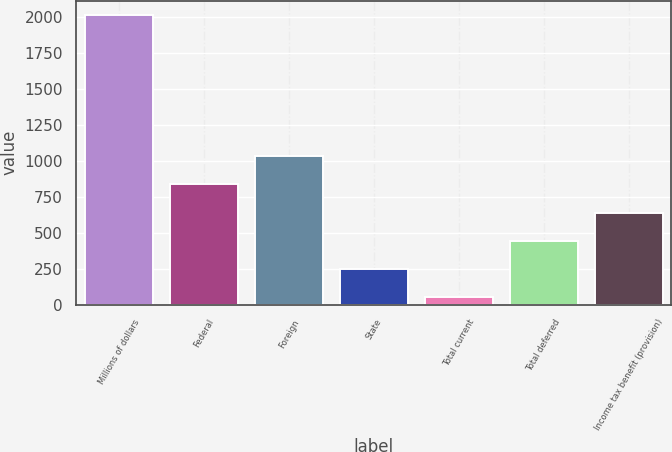Convert chart to OTSL. <chart><loc_0><loc_0><loc_500><loc_500><bar_chart><fcel>Millions of dollars<fcel>Federal<fcel>Foreign<fcel>State<fcel>Total current<fcel>Total deferred<fcel>Income tax benefit (provision)<nl><fcel>2015<fcel>836<fcel>1032.5<fcel>246.5<fcel>50<fcel>443<fcel>639.5<nl></chart> 